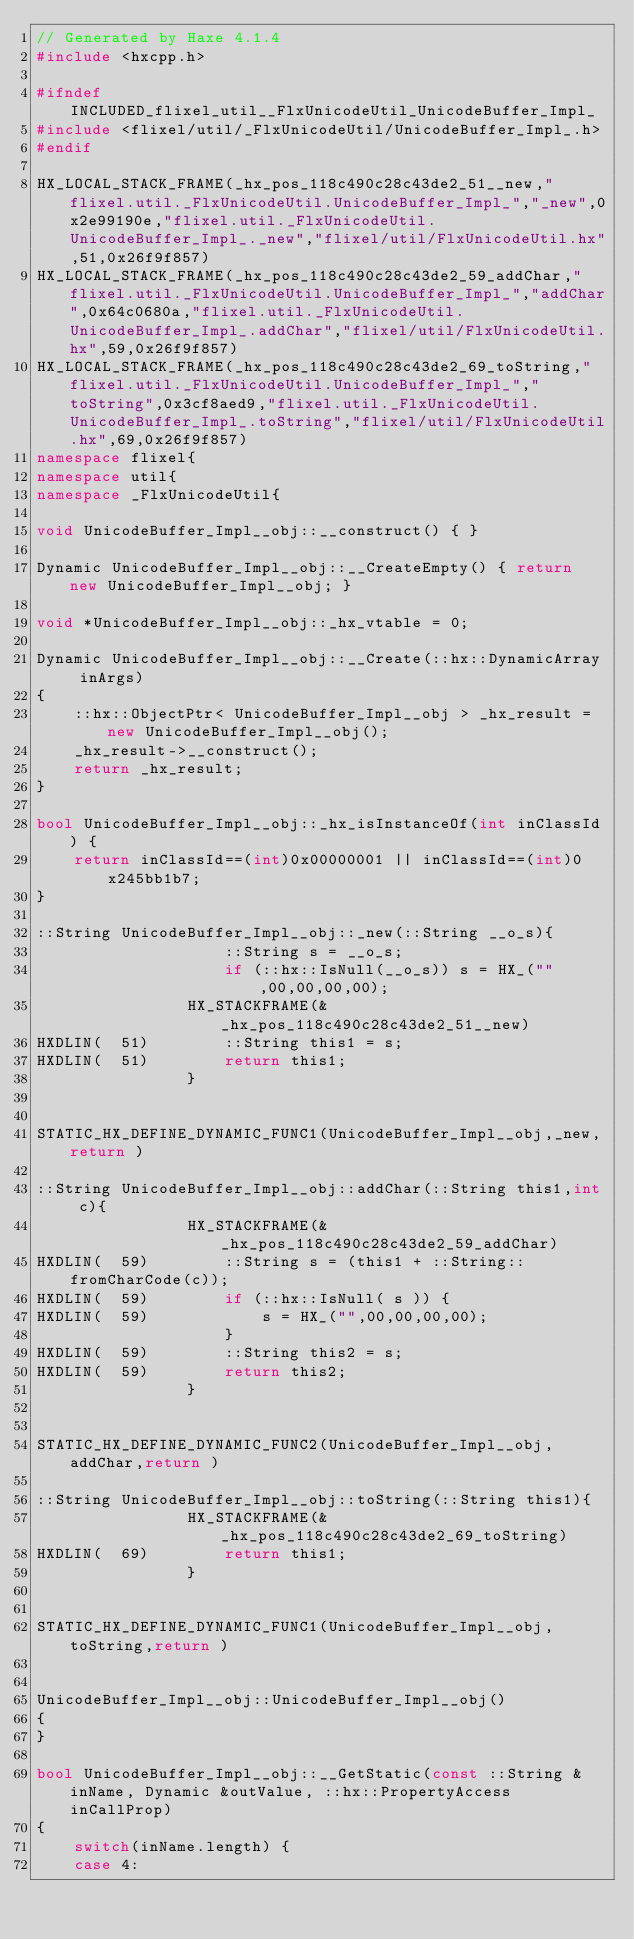<code> <loc_0><loc_0><loc_500><loc_500><_C++_>// Generated by Haxe 4.1.4
#include <hxcpp.h>

#ifndef INCLUDED_flixel_util__FlxUnicodeUtil_UnicodeBuffer_Impl_
#include <flixel/util/_FlxUnicodeUtil/UnicodeBuffer_Impl_.h>
#endif

HX_LOCAL_STACK_FRAME(_hx_pos_118c490c28c43de2_51__new,"flixel.util._FlxUnicodeUtil.UnicodeBuffer_Impl_","_new",0x2e99190e,"flixel.util._FlxUnicodeUtil.UnicodeBuffer_Impl_._new","flixel/util/FlxUnicodeUtil.hx",51,0x26f9f857)
HX_LOCAL_STACK_FRAME(_hx_pos_118c490c28c43de2_59_addChar,"flixel.util._FlxUnicodeUtil.UnicodeBuffer_Impl_","addChar",0x64c0680a,"flixel.util._FlxUnicodeUtil.UnicodeBuffer_Impl_.addChar","flixel/util/FlxUnicodeUtil.hx",59,0x26f9f857)
HX_LOCAL_STACK_FRAME(_hx_pos_118c490c28c43de2_69_toString,"flixel.util._FlxUnicodeUtil.UnicodeBuffer_Impl_","toString",0x3cf8aed9,"flixel.util._FlxUnicodeUtil.UnicodeBuffer_Impl_.toString","flixel/util/FlxUnicodeUtil.hx",69,0x26f9f857)
namespace flixel{
namespace util{
namespace _FlxUnicodeUtil{

void UnicodeBuffer_Impl__obj::__construct() { }

Dynamic UnicodeBuffer_Impl__obj::__CreateEmpty() { return new UnicodeBuffer_Impl__obj; }

void *UnicodeBuffer_Impl__obj::_hx_vtable = 0;

Dynamic UnicodeBuffer_Impl__obj::__Create(::hx::DynamicArray inArgs)
{
	::hx::ObjectPtr< UnicodeBuffer_Impl__obj > _hx_result = new UnicodeBuffer_Impl__obj();
	_hx_result->__construct();
	return _hx_result;
}

bool UnicodeBuffer_Impl__obj::_hx_isInstanceOf(int inClassId) {
	return inClassId==(int)0x00000001 || inClassId==(int)0x245bb1b7;
}

::String UnicodeBuffer_Impl__obj::_new(::String __o_s){
            		::String s = __o_s;
            		if (::hx::IsNull(__o_s)) s = HX_("",00,00,00,00);
            	HX_STACKFRAME(&_hx_pos_118c490c28c43de2_51__new)
HXDLIN(  51)		::String this1 = s;
HXDLIN(  51)		return this1;
            	}


STATIC_HX_DEFINE_DYNAMIC_FUNC1(UnicodeBuffer_Impl__obj,_new,return )

::String UnicodeBuffer_Impl__obj::addChar(::String this1,int c){
            	HX_STACKFRAME(&_hx_pos_118c490c28c43de2_59_addChar)
HXDLIN(  59)		::String s = (this1 + ::String::fromCharCode(c));
HXDLIN(  59)		if (::hx::IsNull( s )) {
HXDLIN(  59)			s = HX_("",00,00,00,00);
            		}
HXDLIN(  59)		::String this2 = s;
HXDLIN(  59)		return this2;
            	}


STATIC_HX_DEFINE_DYNAMIC_FUNC2(UnicodeBuffer_Impl__obj,addChar,return )

::String UnicodeBuffer_Impl__obj::toString(::String this1){
            	HX_STACKFRAME(&_hx_pos_118c490c28c43de2_69_toString)
HXDLIN(  69)		return this1;
            	}


STATIC_HX_DEFINE_DYNAMIC_FUNC1(UnicodeBuffer_Impl__obj,toString,return )


UnicodeBuffer_Impl__obj::UnicodeBuffer_Impl__obj()
{
}

bool UnicodeBuffer_Impl__obj::__GetStatic(const ::String &inName, Dynamic &outValue, ::hx::PropertyAccess inCallProp)
{
	switch(inName.length) {
	case 4:</code> 